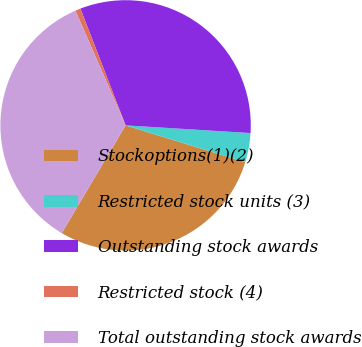Convert chart to OTSL. <chart><loc_0><loc_0><loc_500><loc_500><pie_chart><fcel>Stockoptions(1)(2)<fcel>Restricted stock units (3)<fcel>Outstanding stock awards<fcel>Restricted stock (4)<fcel>Total outstanding stock awards<nl><fcel>28.77%<fcel>3.77%<fcel>31.85%<fcel>0.69%<fcel>34.92%<nl></chart> 